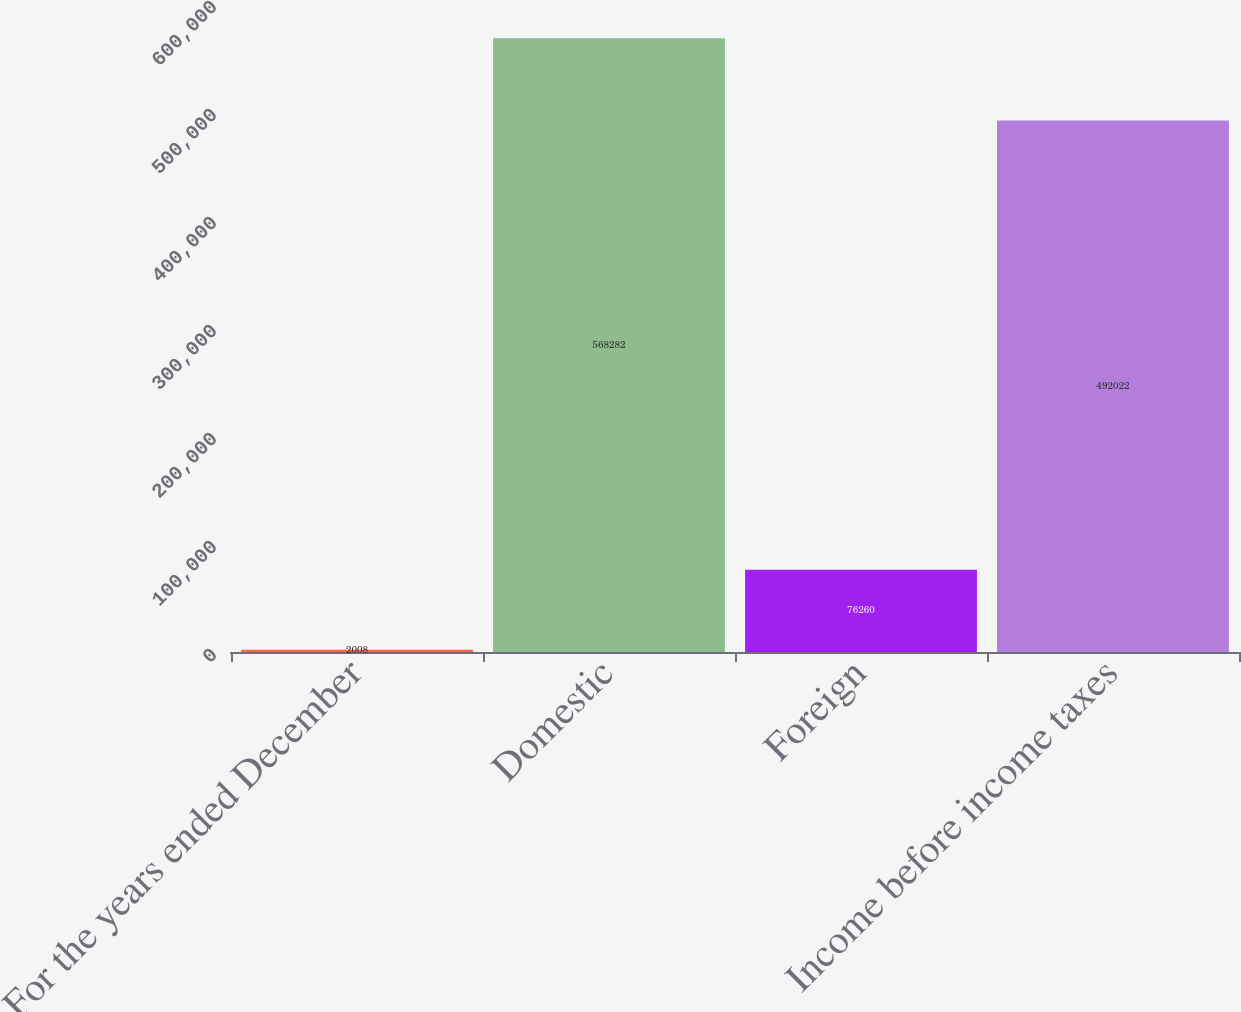Convert chart to OTSL. <chart><loc_0><loc_0><loc_500><loc_500><bar_chart><fcel>For the years ended December<fcel>Domestic<fcel>Foreign<fcel>Income before income taxes<nl><fcel>2008<fcel>568282<fcel>76260<fcel>492022<nl></chart> 